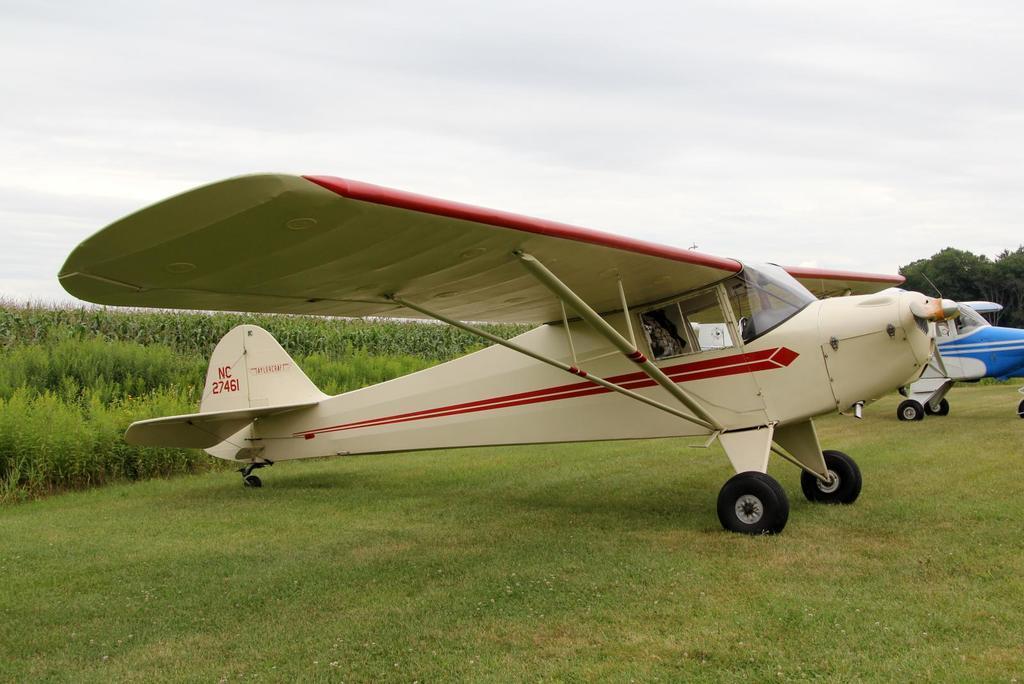In one or two sentences, can you explain what this image depicts? In this picture there are aircraft in the center of the image on the grassland and there is greenery in the background area of the image. 